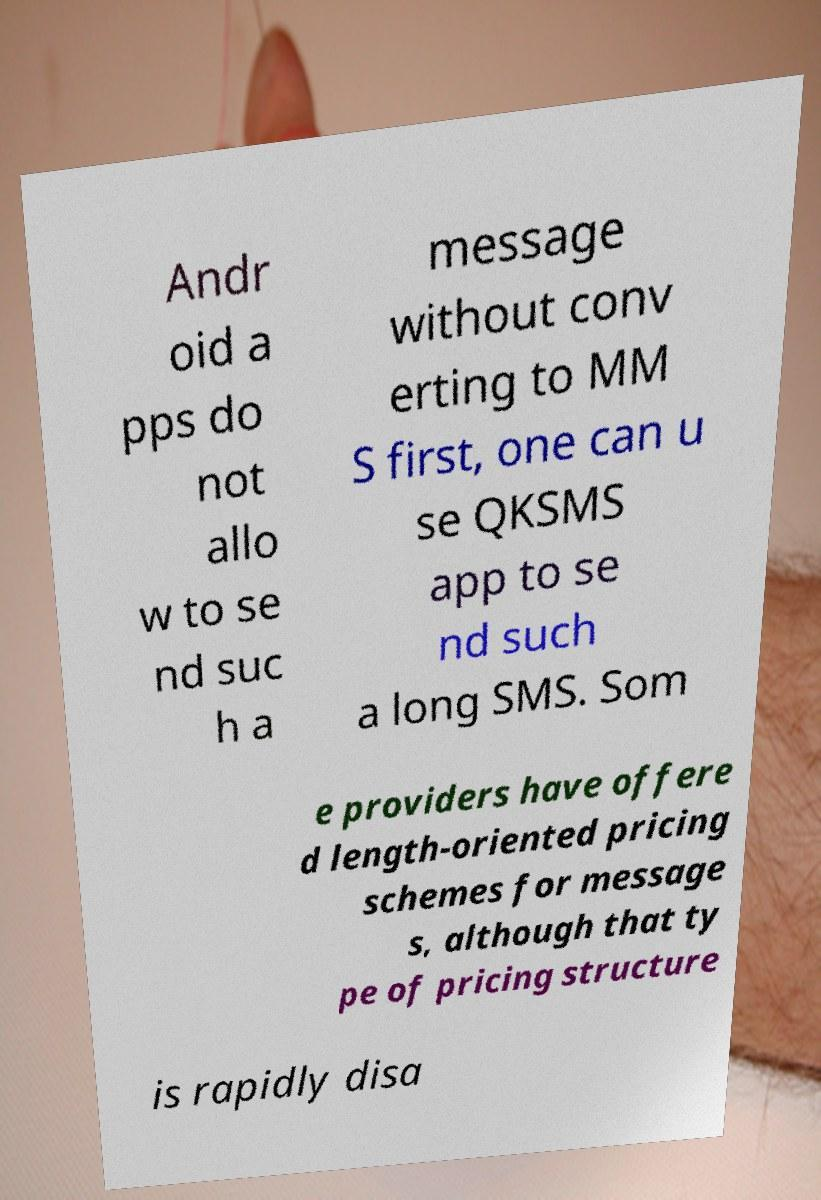Please read and relay the text visible in this image. What does it say? Andr oid a pps do not allo w to se nd suc h a message without conv erting to MM S first, one can u se QKSMS app to se nd such a long SMS. Som e providers have offere d length-oriented pricing schemes for message s, although that ty pe of pricing structure is rapidly disa 